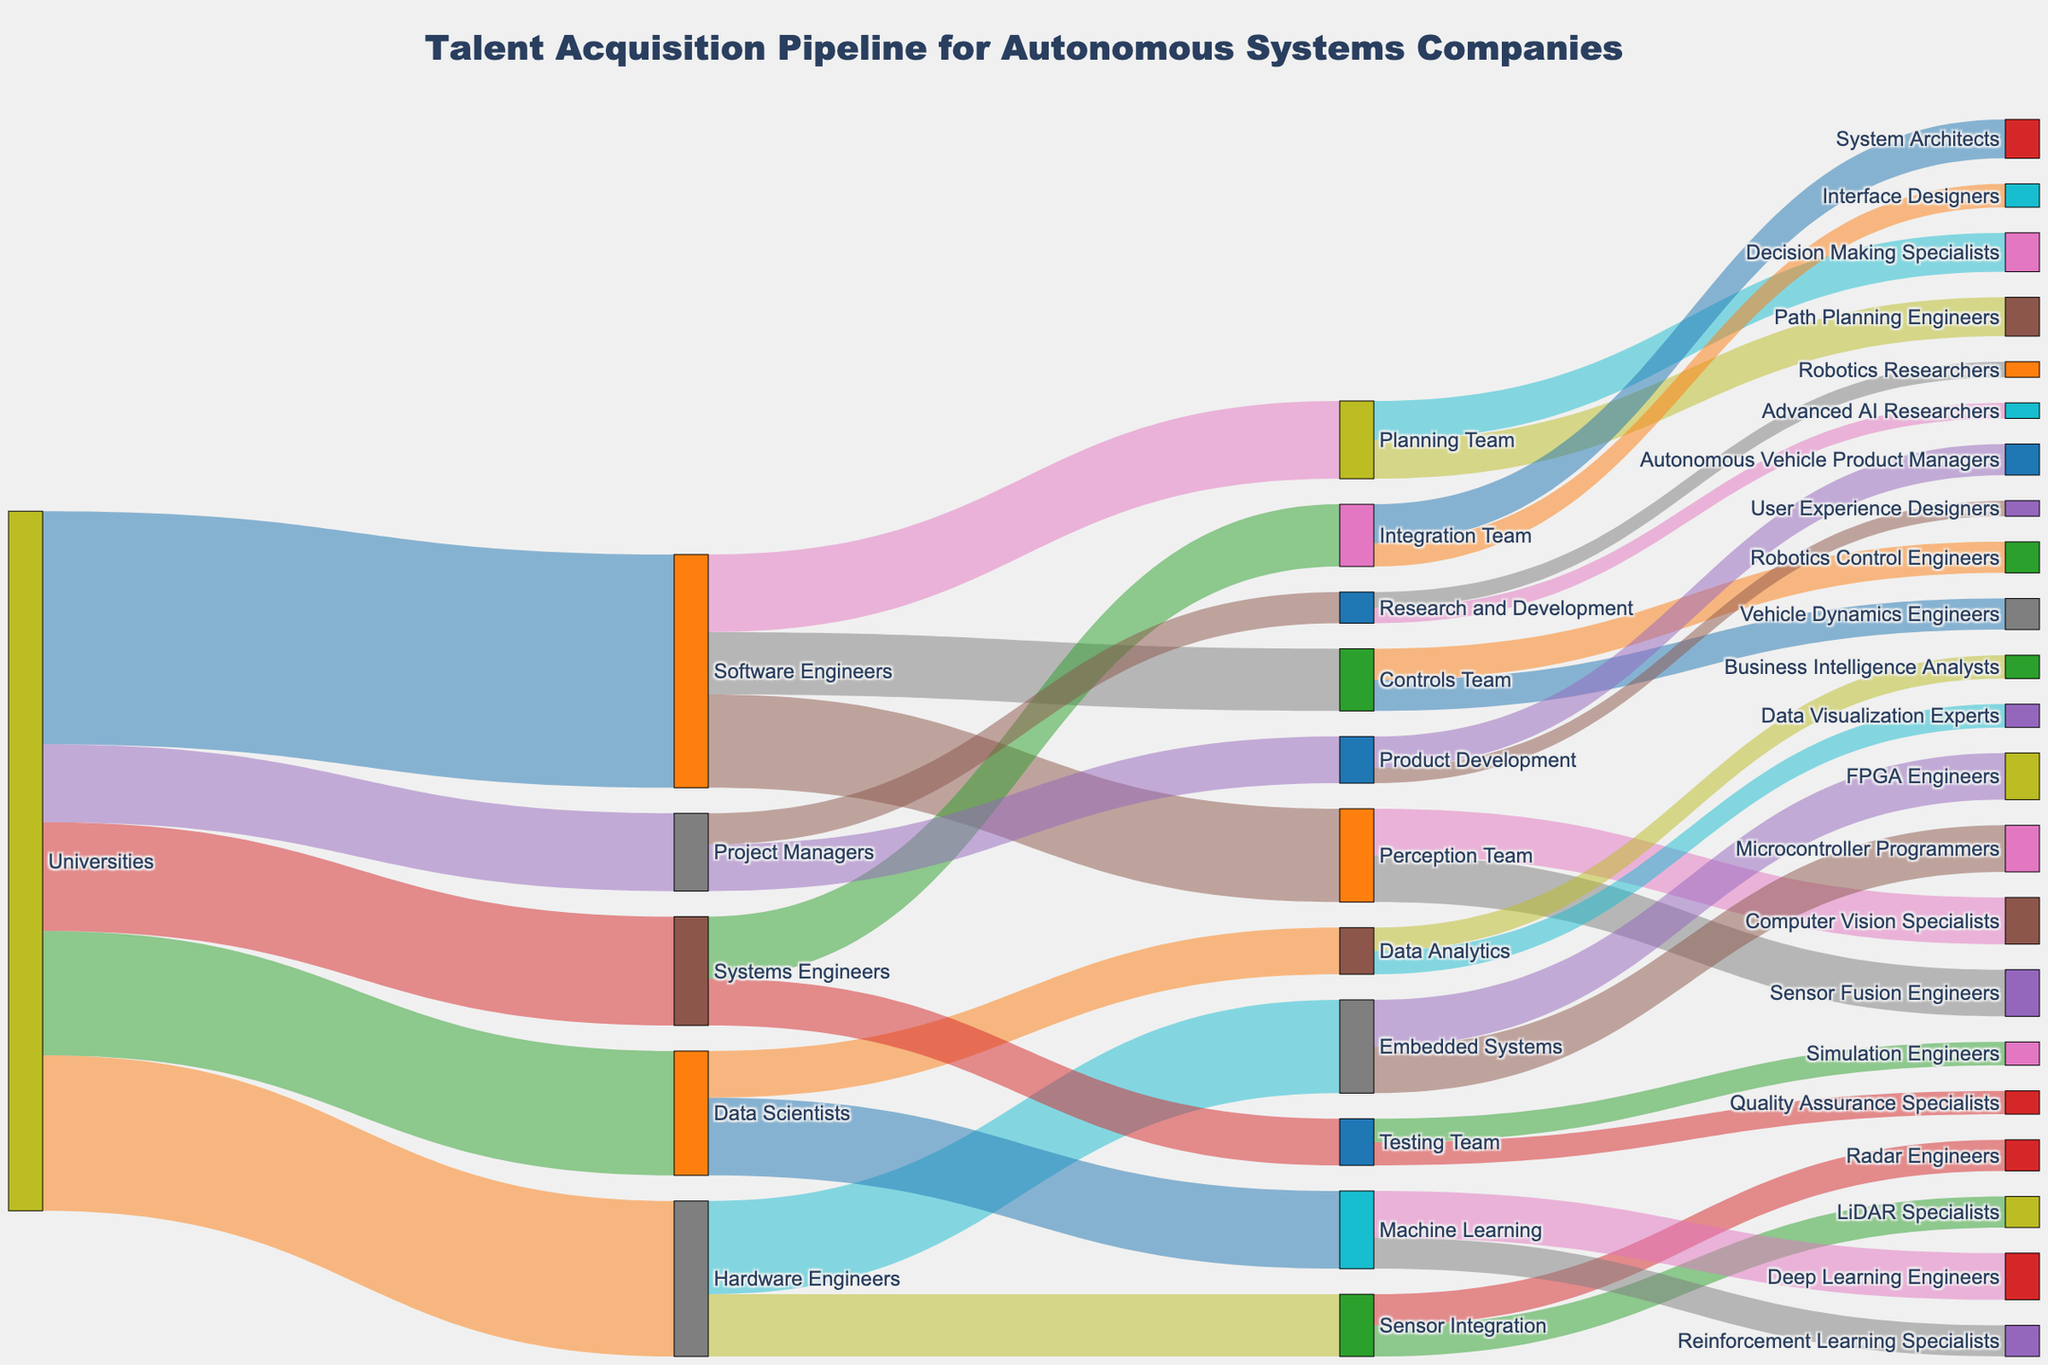What's the largest group coming from Universities? The width of the links from Universities to the different roles represents the number of individuals. The widest link from Universities is to Software Engineers.
Answer: Software Engineers How many individuals transition from Software Engineers to different teams? The number of individuals transitioning from Software Engineers can be found by summing the values of the links from Software Engineers: 60 (Perception Team) + 50 (Planning Team) + 40 (Controls Team).
Answer: 150 What is the total number of Data Scientists and where do they go? There are 80 Data Scientists from Universities. They are distributed into Machine Learning (50) and Data Analytics (30).
Answer: 80; Machine Learning (50), Data Analytics (30) Compare the number of Project Managers going to Product Development versus Research and Development. The link width for Project Managers going to Product Development is 30, while for Research and Development it is 20.
Answer: Product Development: 30, Research and Development: 20 Which specific roles do individuals in the Perception Team transition to, and in what numbers? The Perception Team divides into Computer Vision Specialists (30) and Sensor Fusion Engineers (30).
Answer: Computer Vision Specialists: 30, Sensor Fusion Engineers: 30 How many individuals are involved in Sensor Integration and Embedded Systems from Hardware Engineers? From Hardware Engineers, 40 individuals go to Sensor Integration and 60 to Embedded Systems. Summing these gives us a total of 100.
Answer: 100 Is the total number of individuals in the Systems Engineers team greater or fewer than in the Data Scientists team? Comparing the values, Systems Engineers have 70 individuals while Data Scientists have 80 from Universities.
Answer: Fewer How does the transition of individuals from Software Engineers differ between Perception Team and Controls Team? From Software Engineers, 60 individuals go to the Perception Team and 40 go to the Controls Team.
Answer: Perception Team: 60, Controls Team: 40 Which sub-team has the smallest number of individuals and what function does it perform? Viewing the smallest links, the teams with width values of 10 are Research and Development sub-roles: Advanced AI Researchers and Robotics Researchers.
Answer: Advanced AI Researchers and Robotics Researchers (10 each) How do the roles within the Integration Team breakout in terms of numbers? The Integration Team is divided into System Architects (25) and Interface Designers (15).
Answer: System Architects: 25, Interface Designers: 15 